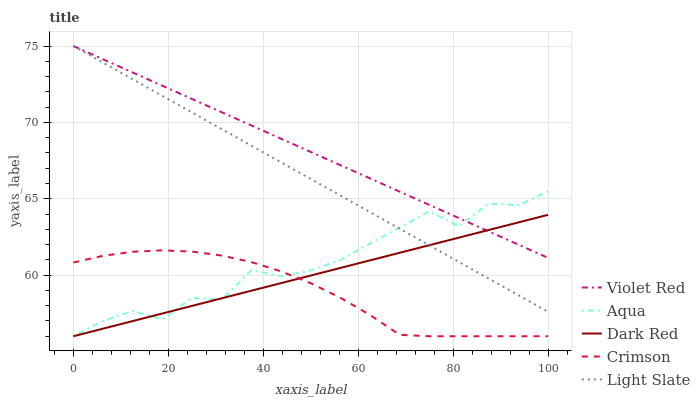Does Dark Red have the minimum area under the curve?
Answer yes or no. No. Does Dark Red have the maximum area under the curve?
Answer yes or no. No. Is Dark Red the smoothest?
Answer yes or no. No. Is Dark Red the roughest?
Answer yes or no. No. Does Violet Red have the lowest value?
Answer yes or no. No. Does Dark Red have the highest value?
Answer yes or no. No. Is Crimson less than Light Slate?
Answer yes or no. Yes. Is Violet Red greater than Crimson?
Answer yes or no. Yes. Does Crimson intersect Light Slate?
Answer yes or no. No. 